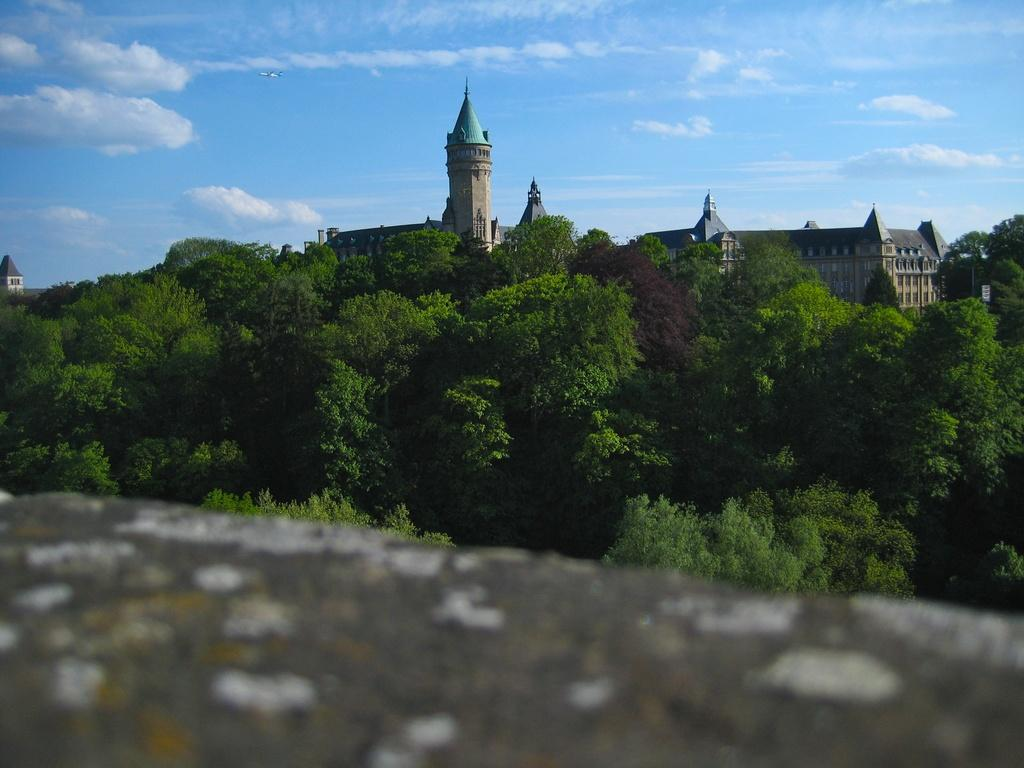What type of natural elements can be seen in the image? There are trees in the image. What type of man-made structures are visible in the background? There are buildings in the background of the image. What part of the natural environment is visible in the image? The sky is visible in the image. What can be observed in the sky? Clouds are present in the sky. Can you see a lake in the image? There is no lake present in the image. What phase of the moon is visible in the image? The moon is not visible in the image; only the sunlit clouds and sky are present. 